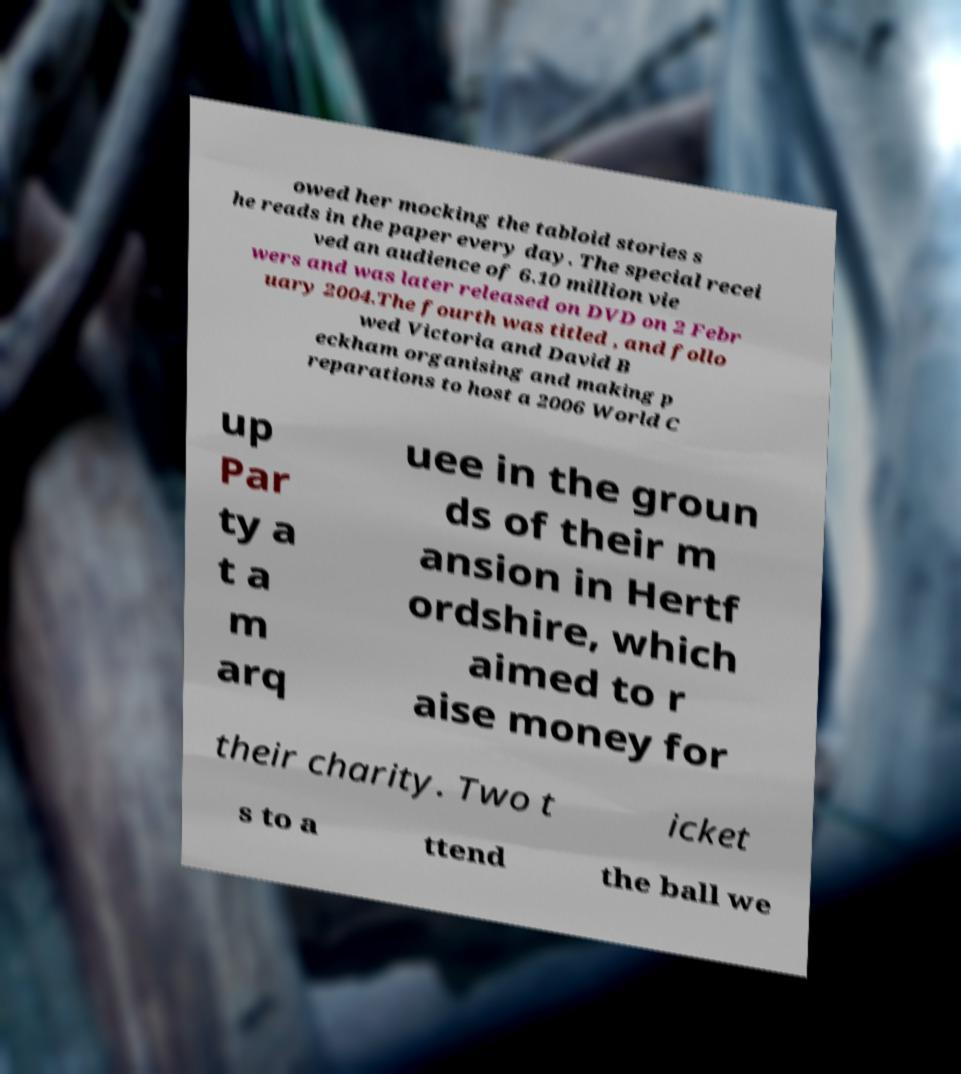What messages or text are displayed in this image? I need them in a readable, typed format. owed her mocking the tabloid stories s he reads in the paper every day. The special recei ved an audience of 6.10 million vie wers and was later released on DVD on 2 Febr uary 2004.The fourth was titled , and follo wed Victoria and David B eckham organising and making p reparations to host a 2006 World C up Par ty a t a m arq uee in the groun ds of their m ansion in Hertf ordshire, which aimed to r aise money for their charity. Two t icket s to a ttend the ball we 